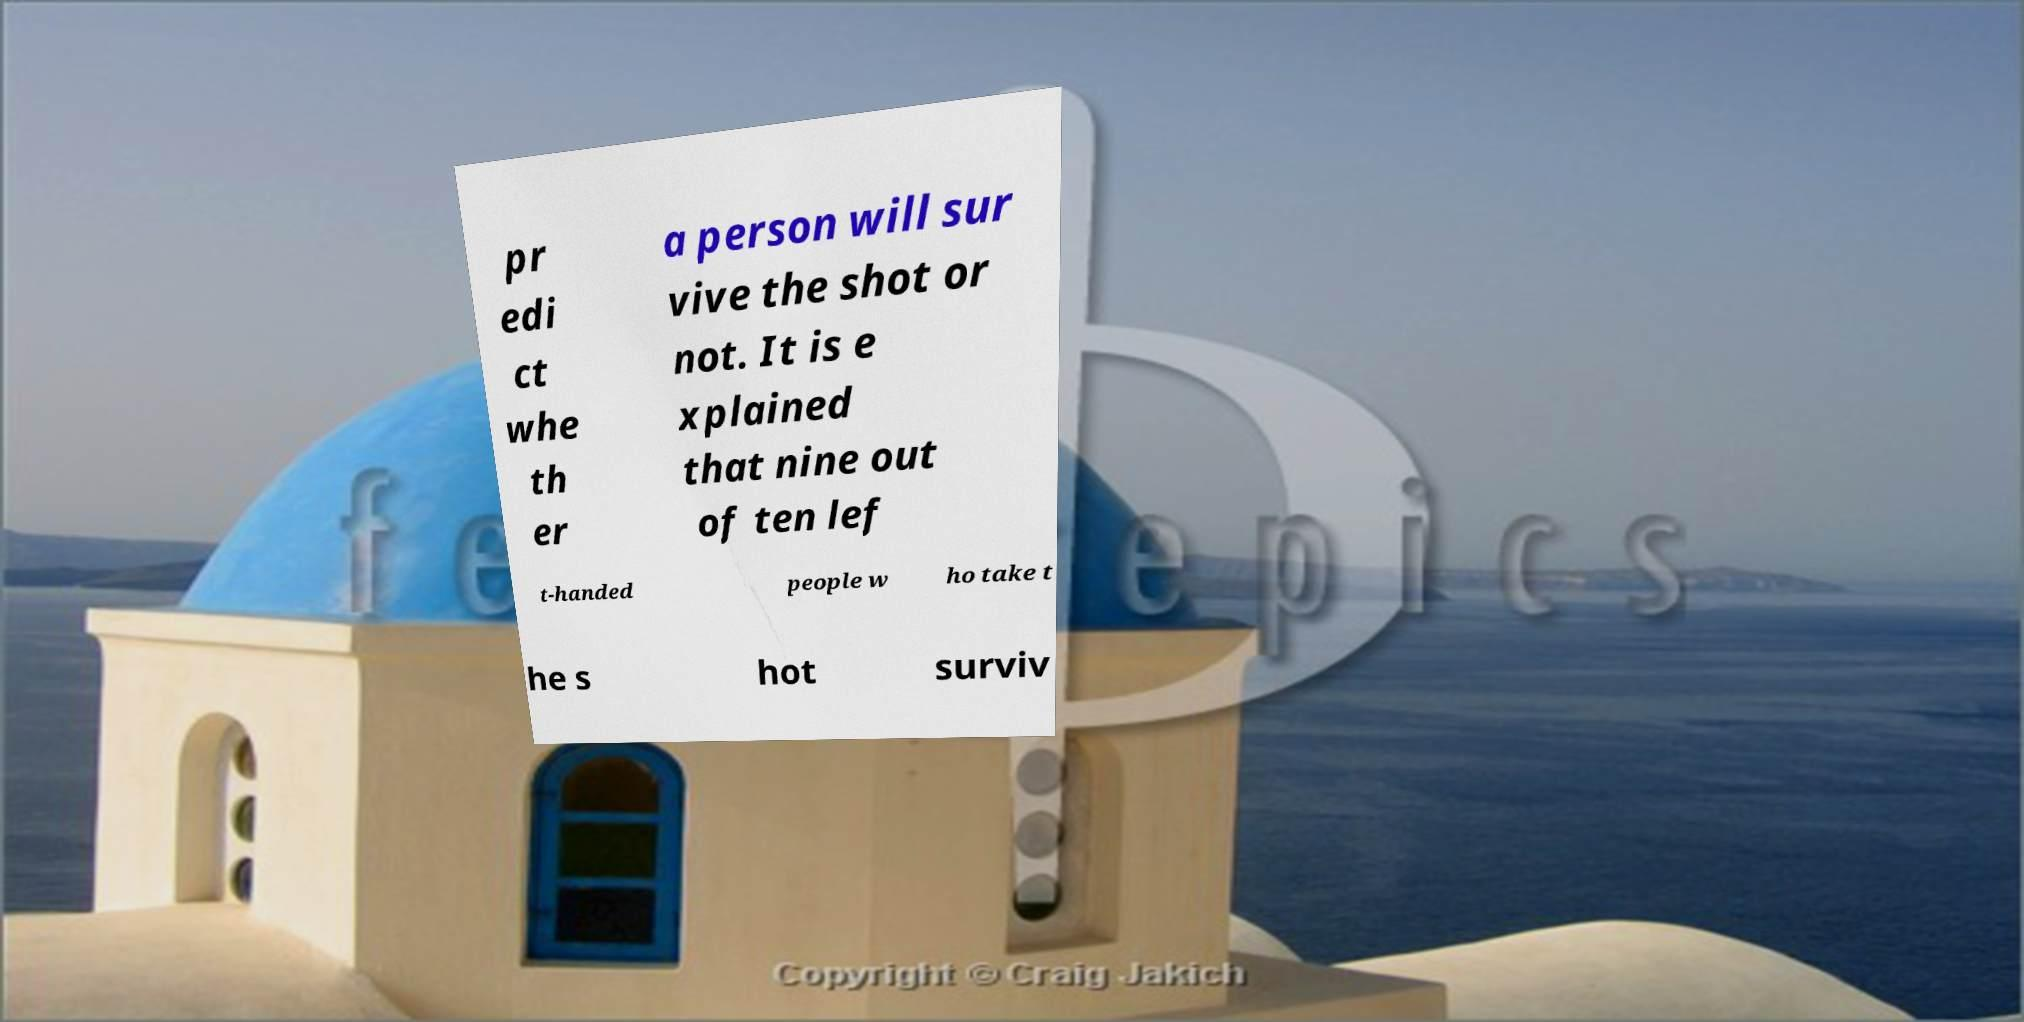Could you assist in decoding the text presented in this image and type it out clearly? pr edi ct whe th er a person will sur vive the shot or not. It is e xplained that nine out of ten lef t-handed people w ho take t he s hot surviv 